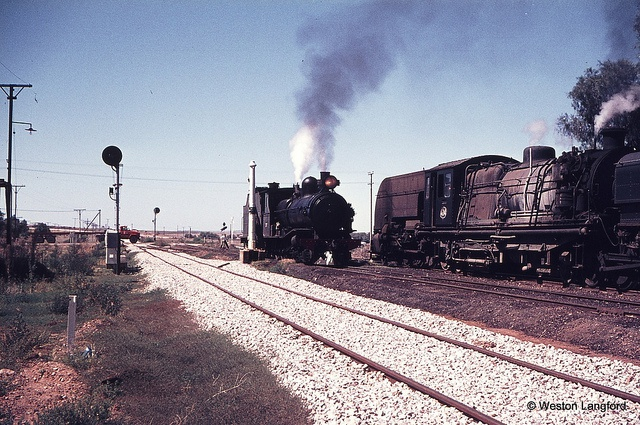Describe the objects in this image and their specific colors. I can see train in blue, black, purple, and darkgray tones and train in blue, black, gray, and purple tones in this image. 